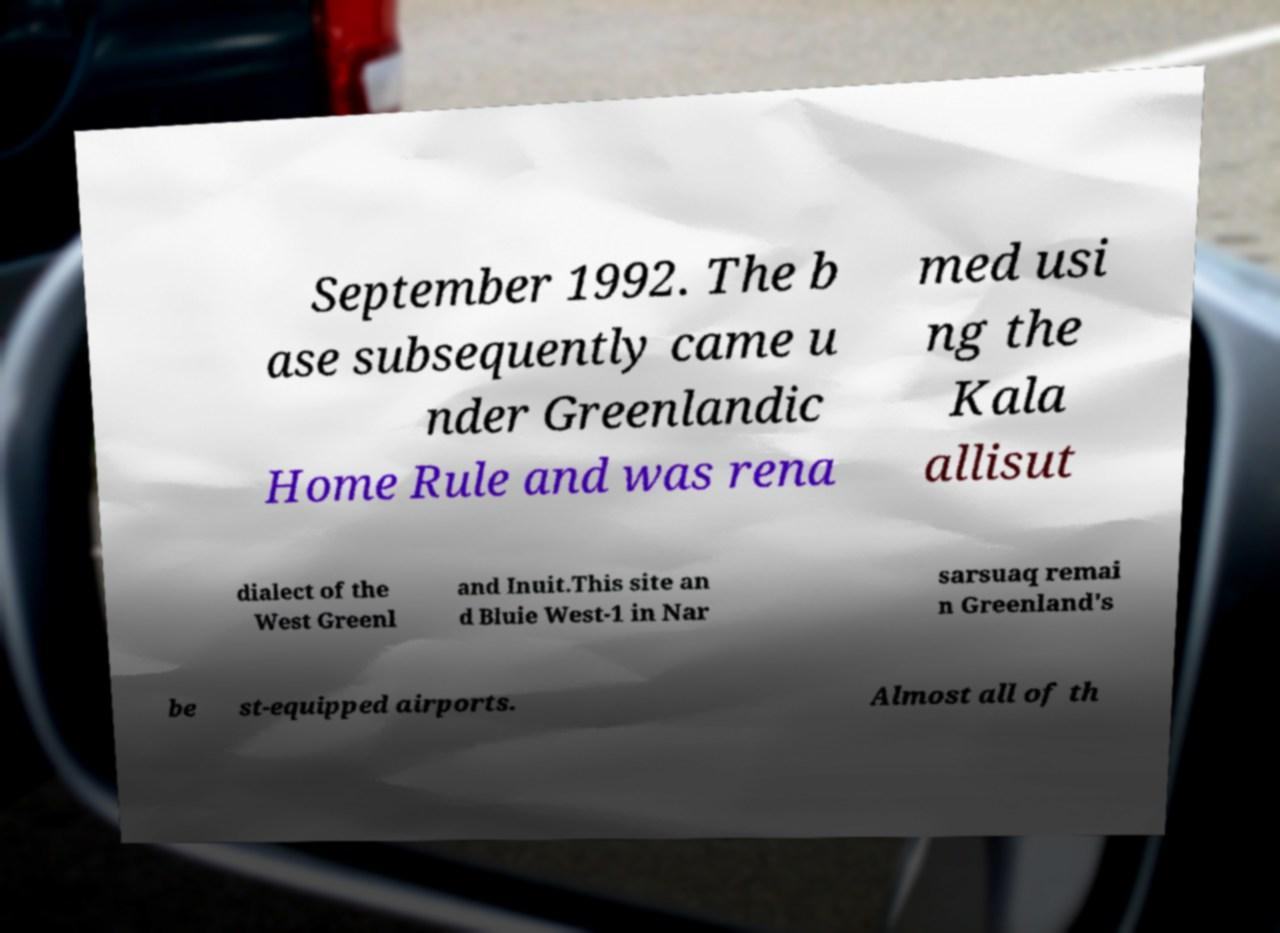Could you extract and type out the text from this image? September 1992. The b ase subsequently came u nder Greenlandic Home Rule and was rena med usi ng the Kala allisut dialect of the West Greenl and Inuit.This site an d Bluie West-1 in Nar sarsuaq remai n Greenland's be st-equipped airports. Almost all of th 